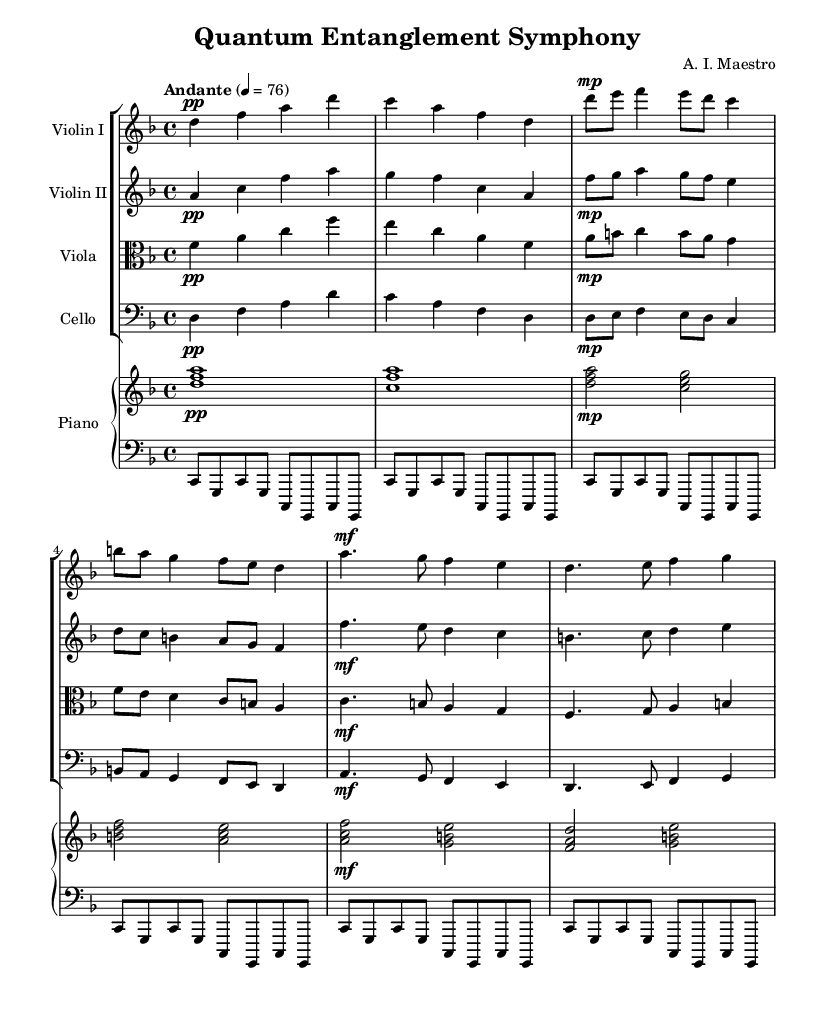What is the key signature of this music? The key signature is indicated by the placement of sharps or flats at the beginning of the staff. In this case, the absence of any sharps or flats indicates that the music is in D minor, which has one flat, B flat, but is written as a relative of F major.
Answer: D minor What is the time signature of this piece? The time signature is denoted at the beginning of the score, right after the key signature. Here, it is written as 4/4, which indicates that there are four beats in each measure and a quarter note receives one beat.
Answer: 4/4 What is the tempo marking for this composition? The tempo is specified at the beginning of the score with the instruction "Andante" along with a metronome marking of quarter note = 76. This indicates a moderate walking speed tempo.
Answer: Andante How many measures are there in the introduction? The introduction consists of a total of 4 measures, which can be counted by looking at the bar lines separating the measures in the sheet music.
Answer: 4 What dynamic marking is indicated at the start of the piece for Violin I? The dynamic marking for Violin I at the start of the piece is marked as "pp" (pianissimo), which instructs the player to perform very softly. This is visible right before the first note in the introduction.
Answer: pp Which instruments are included in this score? The score includes a violin I, a violin II, a viola, a cello, and a piano, as indicated by the headings for each staff set. This grouping shows the ensemble used for the performance.
Answer: Violin I, Violin II, Viola, Cello, Piano 